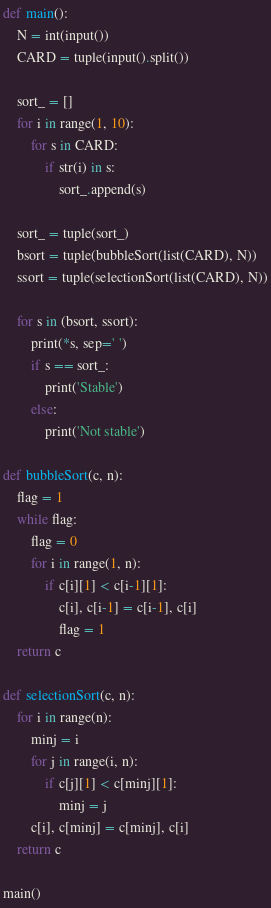<code> <loc_0><loc_0><loc_500><loc_500><_Python_>def main():
    N = int(input())
    CARD = tuple(input().split())

    sort_ = []
    for i in range(1, 10):
        for s in CARD:
            if str(i) in s:
                sort_.append(s)

    sort_ = tuple(sort_)
    bsort = tuple(bubbleSort(list(CARD), N))
    ssort = tuple(selectionSort(list(CARD), N))

    for s in (bsort, ssort):
        print(*s, sep=' ')
        if s == sort_:
            print('Stable')
        else:
            print('Not stable')

def bubbleSort(c, n):
    flag = 1
    while flag:
        flag = 0
        for i in range(1, n):
            if c[i][1] < c[i-1][1]:
                c[i], c[i-1] = c[i-1], c[i]
                flag = 1
    return c

def selectionSort(c, n):
    for i in range(n):
        minj = i
        for j in range(i, n):
            if c[j][1] < c[minj][1]:
                minj = j
        c[i], c[minj] = c[minj], c[i]
    return c

main()</code> 